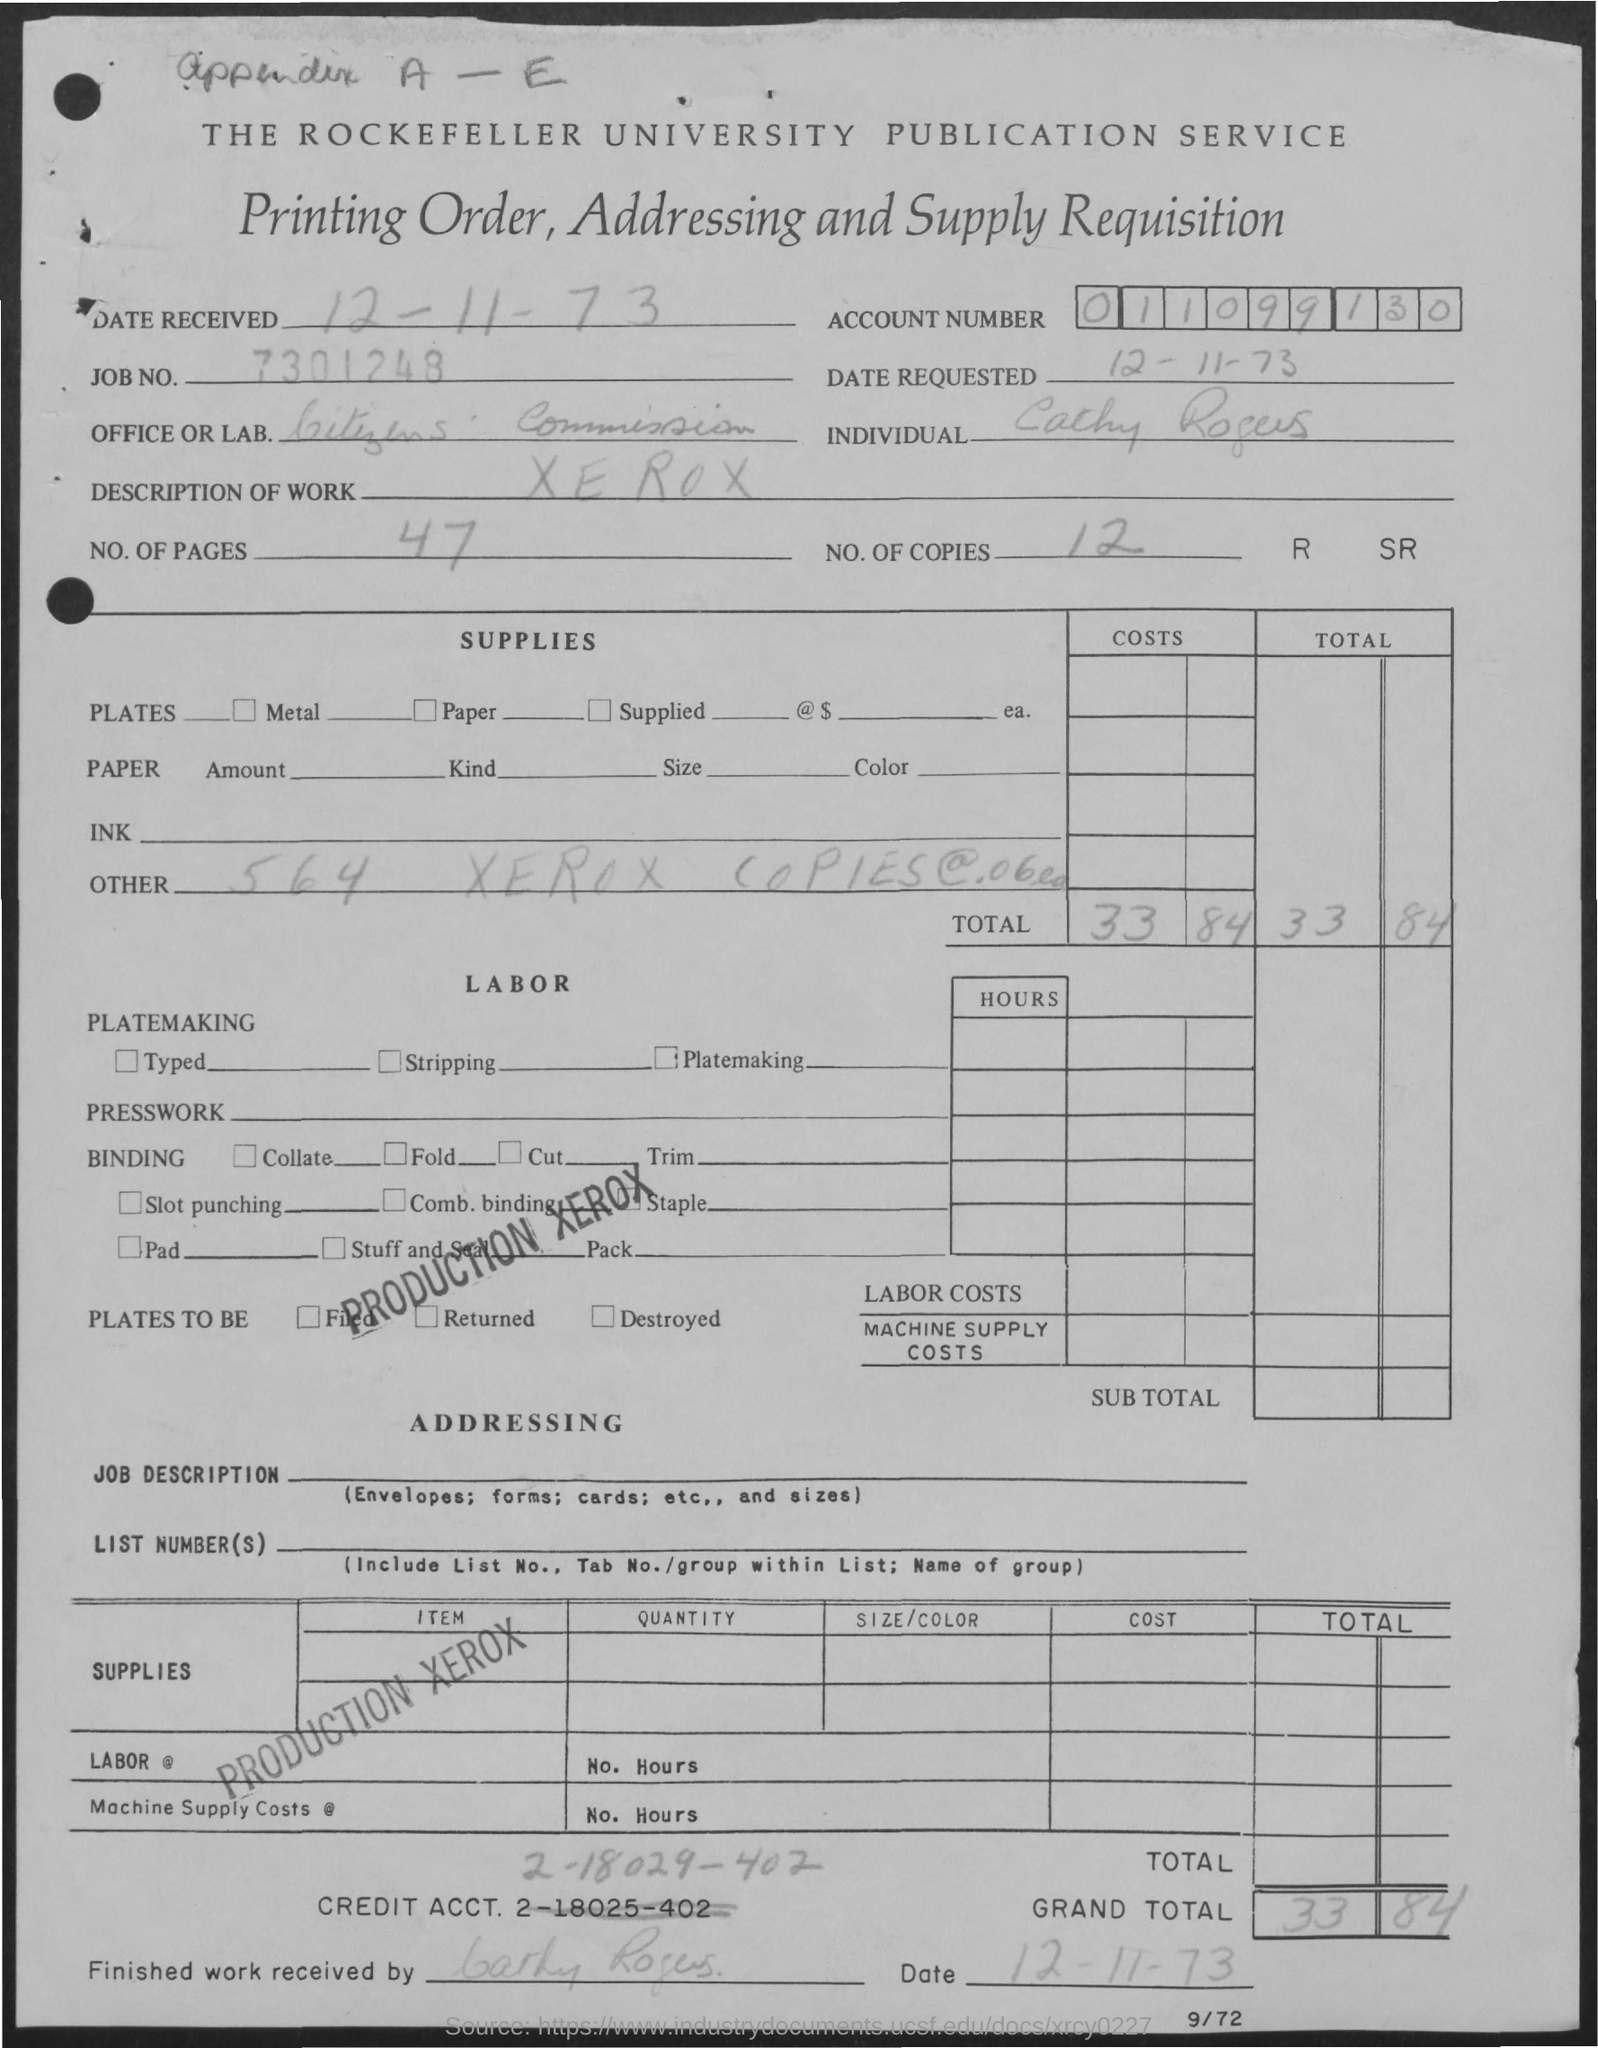List a handful of essential elements in this visual. Xerox is described as work on the given page. The value of the grand total mentioned in the given page is 33 and 84. The given page mentions the name of an office or lab as "Citizens Commission. Fourty-seven pages are mentioned in the given order. The given page mentions 12 copies. 